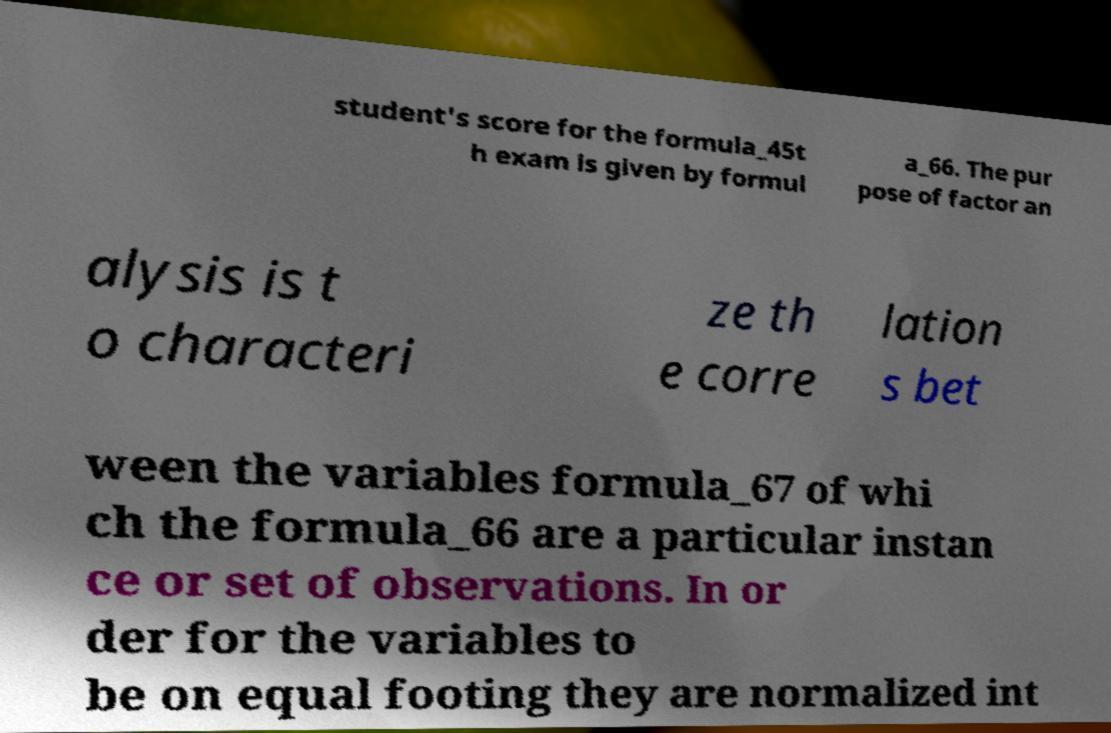Could you extract and type out the text from this image? student's score for the formula_45t h exam is given by formul a_66. The pur pose of factor an alysis is t o characteri ze th e corre lation s bet ween the variables formula_67 of whi ch the formula_66 are a particular instan ce or set of observations. In or der for the variables to be on equal footing they are normalized int 